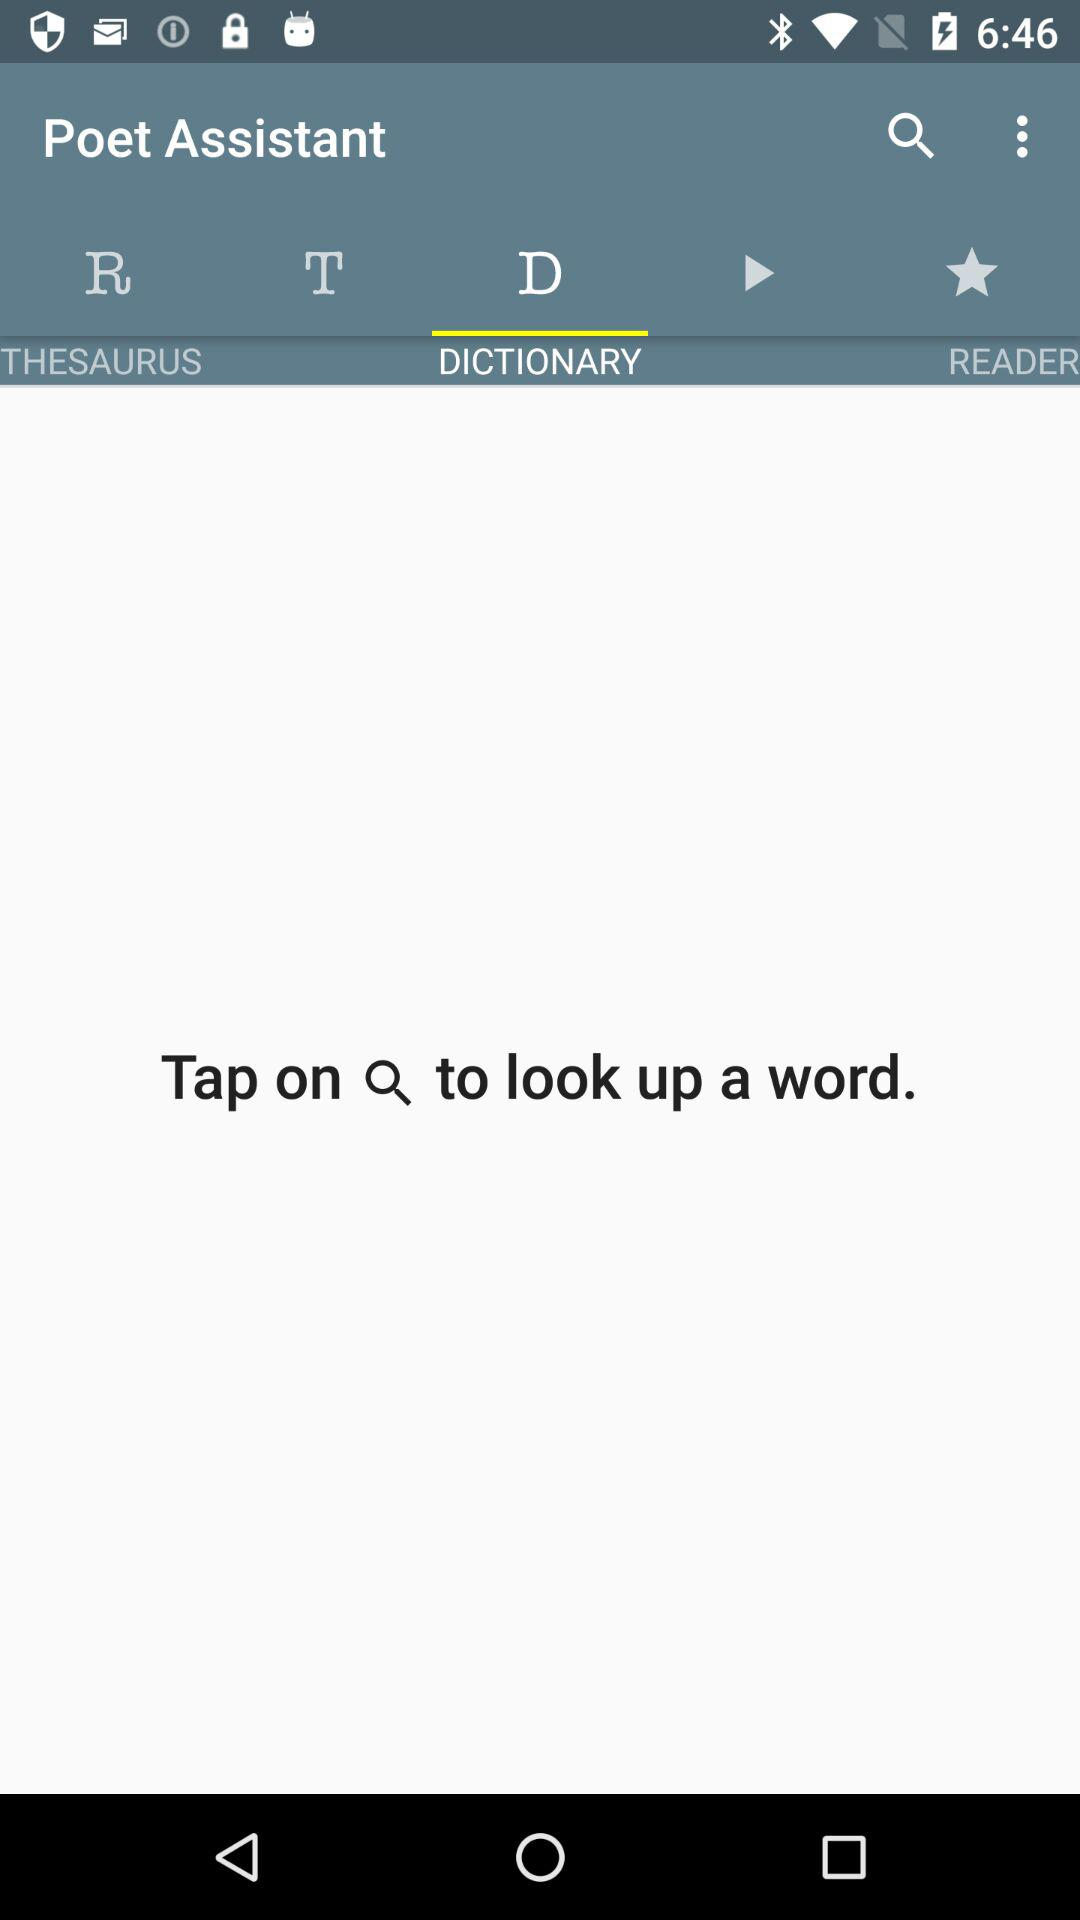Which tab am I using? You are using the "DICTIONARY" tab. 